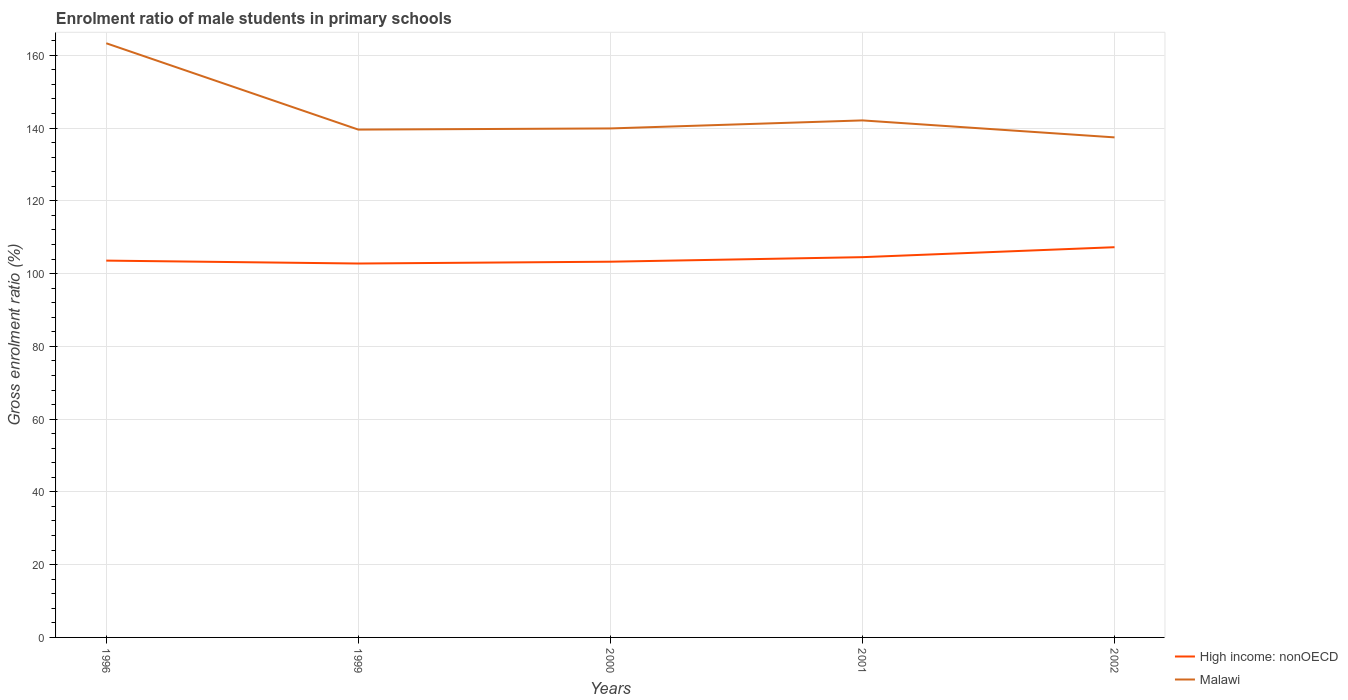Does the line corresponding to High income: nonOECD intersect with the line corresponding to Malawi?
Give a very brief answer. No. Is the number of lines equal to the number of legend labels?
Give a very brief answer. Yes. Across all years, what is the maximum enrolment ratio of male students in primary schools in Malawi?
Offer a very short reply. 137.43. In which year was the enrolment ratio of male students in primary schools in High income: nonOECD maximum?
Offer a terse response. 1999. What is the total enrolment ratio of male students in primary schools in Malawi in the graph?
Offer a very short reply. 21.2. What is the difference between the highest and the second highest enrolment ratio of male students in primary schools in High income: nonOECD?
Make the answer very short. 4.49. What is the difference between two consecutive major ticks on the Y-axis?
Make the answer very short. 20. Are the values on the major ticks of Y-axis written in scientific E-notation?
Offer a very short reply. No. Does the graph contain any zero values?
Offer a very short reply. No. Does the graph contain grids?
Provide a succinct answer. Yes. How are the legend labels stacked?
Your answer should be compact. Vertical. What is the title of the graph?
Your answer should be very brief. Enrolment ratio of male students in primary schools. Does "Latin America(developing only)" appear as one of the legend labels in the graph?
Provide a short and direct response. No. What is the label or title of the Y-axis?
Your answer should be compact. Gross enrolment ratio (%). What is the Gross enrolment ratio (%) of High income: nonOECD in 1996?
Offer a very short reply. 103.56. What is the Gross enrolment ratio (%) of Malawi in 1996?
Provide a short and direct response. 163.3. What is the Gross enrolment ratio (%) in High income: nonOECD in 1999?
Your answer should be very brief. 102.76. What is the Gross enrolment ratio (%) of Malawi in 1999?
Provide a short and direct response. 139.57. What is the Gross enrolment ratio (%) of High income: nonOECD in 2000?
Keep it short and to the point. 103.26. What is the Gross enrolment ratio (%) of Malawi in 2000?
Ensure brevity in your answer.  139.89. What is the Gross enrolment ratio (%) in High income: nonOECD in 2001?
Give a very brief answer. 104.51. What is the Gross enrolment ratio (%) of Malawi in 2001?
Keep it short and to the point. 142.1. What is the Gross enrolment ratio (%) of High income: nonOECD in 2002?
Keep it short and to the point. 107.25. What is the Gross enrolment ratio (%) in Malawi in 2002?
Offer a terse response. 137.43. Across all years, what is the maximum Gross enrolment ratio (%) of High income: nonOECD?
Provide a succinct answer. 107.25. Across all years, what is the maximum Gross enrolment ratio (%) in Malawi?
Provide a short and direct response. 163.3. Across all years, what is the minimum Gross enrolment ratio (%) in High income: nonOECD?
Make the answer very short. 102.76. Across all years, what is the minimum Gross enrolment ratio (%) in Malawi?
Keep it short and to the point. 137.43. What is the total Gross enrolment ratio (%) in High income: nonOECD in the graph?
Your answer should be compact. 521.35. What is the total Gross enrolment ratio (%) of Malawi in the graph?
Keep it short and to the point. 722.29. What is the difference between the Gross enrolment ratio (%) of High income: nonOECD in 1996 and that in 1999?
Your answer should be compact. 0.8. What is the difference between the Gross enrolment ratio (%) of Malawi in 1996 and that in 1999?
Your answer should be compact. 23.73. What is the difference between the Gross enrolment ratio (%) of High income: nonOECD in 1996 and that in 2000?
Your answer should be very brief. 0.3. What is the difference between the Gross enrolment ratio (%) in Malawi in 1996 and that in 2000?
Provide a succinct answer. 23.41. What is the difference between the Gross enrolment ratio (%) of High income: nonOECD in 1996 and that in 2001?
Make the answer very short. -0.95. What is the difference between the Gross enrolment ratio (%) in Malawi in 1996 and that in 2001?
Keep it short and to the point. 21.2. What is the difference between the Gross enrolment ratio (%) of High income: nonOECD in 1996 and that in 2002?
Make the answer very short. -3.69. What is the difference between the Gross enrolment ratio (%) in Malawi in 1996 and that in 2002?
Provide a short and direct response. 25.87. What is the difference between the Gross enrolment ratio (%) in High income: nonOECD in 1999 and that in 2000?
Give a very brief answer. -0.5. What is the difference between the Gross enrolment ratio (%) in Malawi in 1999 and that in 2000?
Your answer should be compact. -0.32. What is the difference between the Gross enrolment ratio (%) of High income: nonOECD in 1999 and that in 2001?
Offer a terse response. -1.75. What is the difference between the Gross enrolment ratio (%) in Malawi in 1999 and that in 2001?
Ensure brevity in your answer.  -2.53. What is the difference between the Gross enrolment ratio (%) of High income: nonOECD in 1999 and that in 2002?
Your answer should be very brief. -4.49. What is the difference between the Gross enrolment ratio (%) of Malawi in 1999 and that in 2002?
Give a very brief answer. 2.14. What is the difference between the Gross enrolment ratio (%) of High income: nonOECD in 2000 and that in 2001?
Offer a terse response. -1.25. What is the difference between the Gross enrolment ratio (%) of Malawi in 2000 and that in 2001?
Your answer should be compact. -2.21. What is the difference between the Gross enrolment ratio (%) in High income: nonOECD in 2000 and that in 2002?
Offer a terse response. -3.99. What is the difference between the Gross enrolment ratio (%) in Malawi in 2000 and that in 2002?
Give a very brief answer. 2.46. What is the difference between the Gross enrolment ratio (%) of High income: nonOECD in 2001 and that in 2002?
Offer a very short reply. -2.74. What is the difference between the Gross enrolment ratio (%) in Malawi in 2001 and that in 2002?
Give a very brief answer. 4.67. What is the difference between the Gross enrolment ratio (%) of High income: nonOECD in 1996 and the Gross enrolment ratio (%) of Malawi in 1999?
Your answer should be very brief. -36.01. What is the difference between the Gross enrolment ratio (%) of High income: nonOECD in 1996 and the Gross enrolment ratio (%) of Malawi in 2000?
Offer a very short reply. -36.33. What is the difference between the Gross enrolment ratio (%) in High income: nonOECD in 1996 and the Gross enrolment ratio (%) in Malawi in 2001?
Your answer should be compact. -38.53. What is the difference between the Gross enrolment ratio (%) in High income: nonOECD in 1996 and the Gross enrolment ratio (%) in Malawi in 2002?
Offer a terse response. -33.87. What is the difference between the Gross enrolment ratio (%) in High income: nonOECD in 1999 and the Gross enrolment ratio (%) in Malawi in 2000?
Provide a succinct answer. -37.13. What is the difference between the Gross enrolment ratio (%) in High income: nonOECD in 1999 and the Gross enrolment ratio (%) in Malawi in 2001?
Ensure brevity in your answer.  -39.33. What is the difference between the Gross enrolment ratio (%) of High income: nonOECD in 1999 and the Gross enrolment ratio (%) of Malawi in 2002?
Ensure brevity in your answer.  -34.67. What is the difference between the Gross enrolment ratio (%) of High income: nonOECD in 2000 and the Gross enrolment ratio (%) of Malawi in 2001?
Keep it short and to the point. -38.84. What is the difference between the Gross enrolment ratio (%) in High income: nonOECD in 2000 and the Gross enrolment ratio (%) in Malawi in 2002?
Provide a short and direct response. -34.17. What is the difference between the Gross enrolment ratio (%) of High income: nonOECD in 2001 and the Gross enrolment ratio (%) of Malawi in 2002?
Make the answer very short. -32.92. What is the average Gross enrolment ratio (%) in High income: nonOECD per year?
Provide a short and direct response. 104.27. What is the average Gross enrolment ratio (%) in Malawi per year?
Provide a short and direct response. 144.46. In the year 1996, what is the difference between the Gross enrolment ratio (%) of High income: nonOECD and Gross enrolment ratio (%) of Malawi?
Provide a succinct answer. -59.74. In the year 1999, what is the difference between the Gross enrolment ratio (%) in High income: nonOECD and Gross enrolment ratio (%) in Malawi?
Provide a succinct answer. -36.81. In the year 2000, what is the difference between the Gross enrolment ratio (%) in High income: nonOECD and Gross enrolment ratio (%) in Malawi?
Your answer should be very brief. -36.63. In the year 2001, what is the difference between the Gross enrolment ratio (%) of High income: nonOECD and Gross enrolment ratio (%) of Malawi?
Give a very brief answer. -37.59. In the year 2002, what is the difference between the Gross enrolment ratio (%) in High income: nonOECD and Gross enrolment ratio (%) in Malawi?
Your answer should be very brief. -30.18. What is the ratio of the Gross enrolment ratio (%) in High income: nonOECD in 1996 to that in 1999?
Give a very brief answer. 1.01. What is the ratio of the Gross enrolment ratio (%) of Malawi in 1996 to that in 1999?
Your response must be concise. 1.17. What is the ratio of the Gross enrolment ratio (%) of High income: nonOECD in 1996 to that in 2000?
Make the answer very short. 1. What is the ratio of the Gross enrolment ratio (%) of Malawi in 1996 to that in 2000?
Ensure brevity in your answer.  1.17. What is the ratio of the Gross enrolment ratio (%) in High income: nonOECD in 1996 to that in 2001?
Provide a succinct answer. 0.99. What is the ratio of the Gross enrolment ratio (%) in Malawi in 1996 to that in 2001?
Provide a succinct answer. 1.15. What is the ratio of the Gross enrolment ratio (%) in High income: nonOECD in 1996 to that in 2002?
Your response must be concise. 0.97. What is the ratio of the Gross enrolment ratio (%) in Malawi in 1996 to that in 2002?
Your answer should be very brief. 1.19. What is the ratio of the Gross enrolment ratio (%) of Malawi in 1999 to that in 2000?
Provide a succinct answer. 1. What is the ratio of the Gross enrolment ratio (%) of High income: nonOECD in 1999 to that in 2001?
Offer a terse response. 0.98. What is the ratio of the Gross enrolment ratio (%) in Malawi in 1999 to that in 2001?
Provide a short and direct response. 0.98. What is the ratio of the Gross enrolment ratio (%) of High income: nonOECD in 1999 to that in 2002?
Offer a terse response. 0.96. What is the ratio of the Gross enrolment ratio (%) of Malawi in 1999 to that in 2002?
Offer a terse response. 1.02. What is the ratio of the Gross enrolment ratio (%) of High income: nonOECD in 2000 to that in 2001?
Your answer should be compact. 0.99. What is the ratio of the Gross enrolment ratio (%) of Malawi in 2000 to that in 2001?
Ensure brevity in your answer.  0.98. What is the ratio of the Gross enrolment ratio (%) of High income: nonOECD in 2000 to that in 2002?
Provide a succinct answer. 0.96. What is the ratio of the Gross enrolment ratio (%) in Malawi in 2000 to that in 2002?
Ensure brevity in your answer.  1.02. What is the ratio of the Gross enrolment ratio (%) of High income: nonOECD in 2001 to that in 2002?
Offer a terse response. 0.97. What is the ratio of the Gross enrolment ratio (%) in Malawi in 2001 to that in 2002?
Your response must be concise. 1.03. What is the difference between the highest and the second highest Gross enrolment ratio (%) of High income: nonOECD?
Offer a very short reply. 2.74. What is the difference between the highest and the second highest Gross enrolment ratio (%) of Malawi?
Ensure brevity in your answer.  21.2. What is the difference between the highest and the lowest Gross enrolment ratio (%) of High income: nonOECD?
Offer a very short reply. 4.49. What is the difference between the highest and the lowest Gross enrolment ratio (%) of Malawi?
Provide a short and direct response. 25.87. 